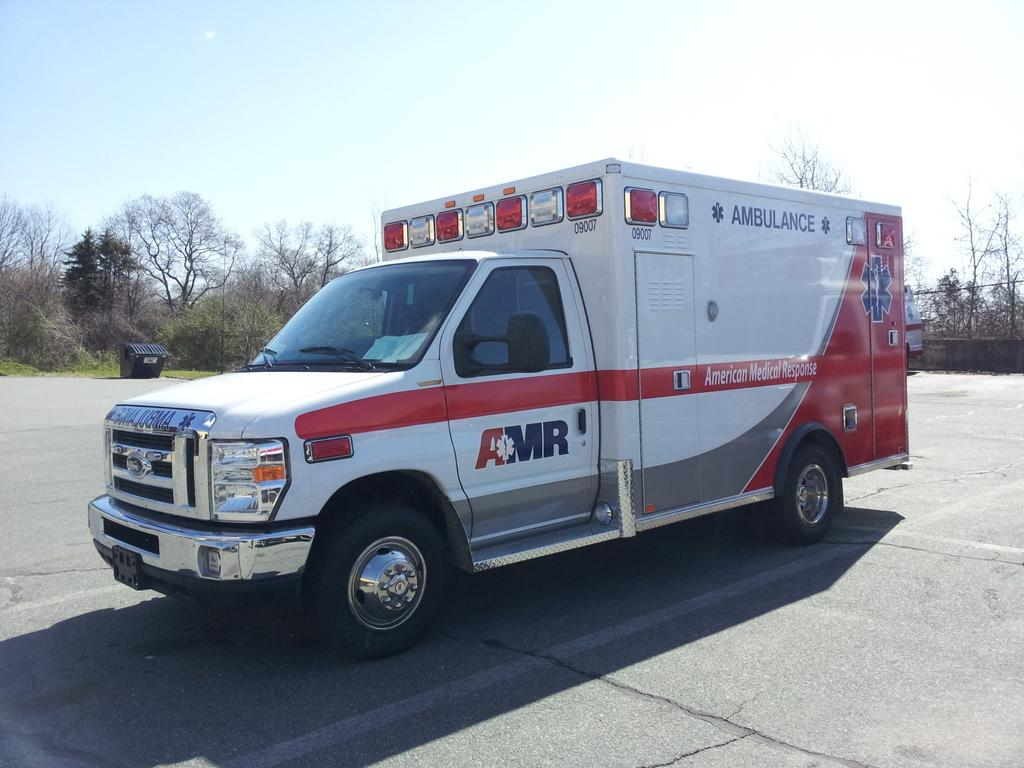What is the main subject in the foreground of the image? There is an ambulance in the foreground of the image. What is the position of the ambulance in the image? The ambulance is on the ground. What can be seen in the background of the image? There is a dustbin, grass, trees, the sky, and fencing in the background of the image. What type of sand can be seen on the beach in the image? There is no beach or sand present in the image; it features an ambulance on the ground with various background elements. 